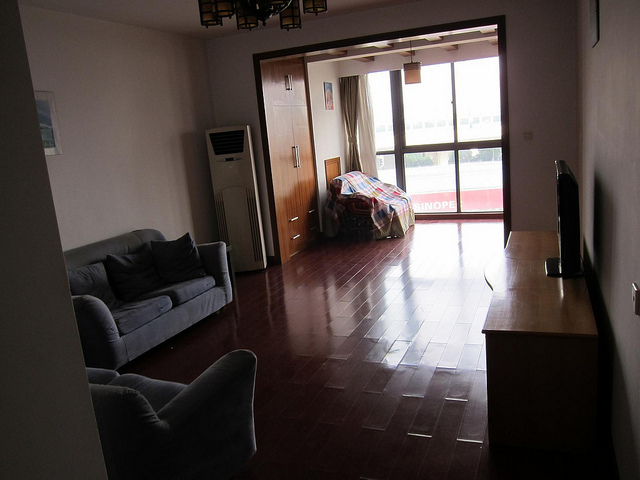<image>What is in the casing? It's ambiguous what is in the casing. The answers vary from a chair, a couch, to wood. What is in the casing? It is not clear what is in the casing. It can be seen a chair, a couch, or something else. 